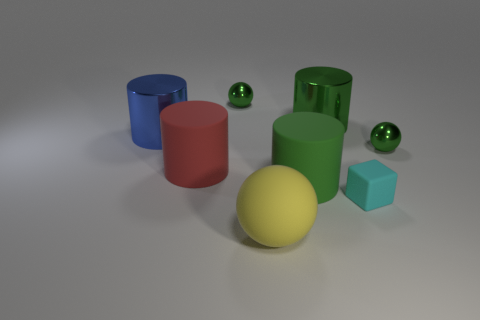Subtract all large blue metal cylinders. How many cylinders are left? 3 Subtract all red cylinders. How many cylinders are left? 3 Subtract all purple cylinders. Subtract all red blocks. How many cylinders are left? 4 Add 2 red objects. How many objects exist? 10 Subtract all balls. How many objects are left? 5 Add 6 blue metal things. How many blue metal things are left? 7 Add 8 rubber cylinders. How many rubber cylinders exist? 10 Subtract 0 red blocks. How many objects are left? 8 Subtract all tiny green matte spheres. Subtract all big matte cylinders. How many objects are left? 6 